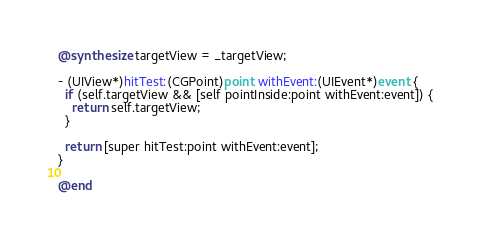<code> <loc_0><loc_0><loc_500><loc_500><_ObjectiveC_>@synthesize targetView = _targetView;

- (UIView*)hitTest:(CGPoint)point withEvent:(UIEvent*)event {
  if (self.targetView && [self pointInside:point withEvent:event]) {
    return self.targetView;
  }

  return [super hitTest:point withEvent:event];
}

@end
</code> 